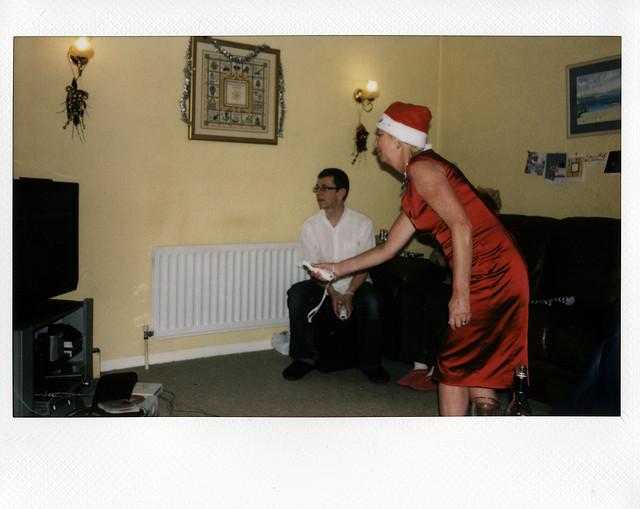What are they playing?
Write a very short answer. Wii. What is the person sitting on?
Be succinct. Couch. Is this a real person?
Write a very short answer. Yes. Is the man hiding his face?
Short answer required. No. What time of year is this?
Concise answer only. Christmas. What is plugged in?
Keep it brief. Tv. Are the people fighting?
Quick response, please. No. What colors are the wall?
Be succinct. Yellow. What animal is all over the wall?
Answer briefly. None. 